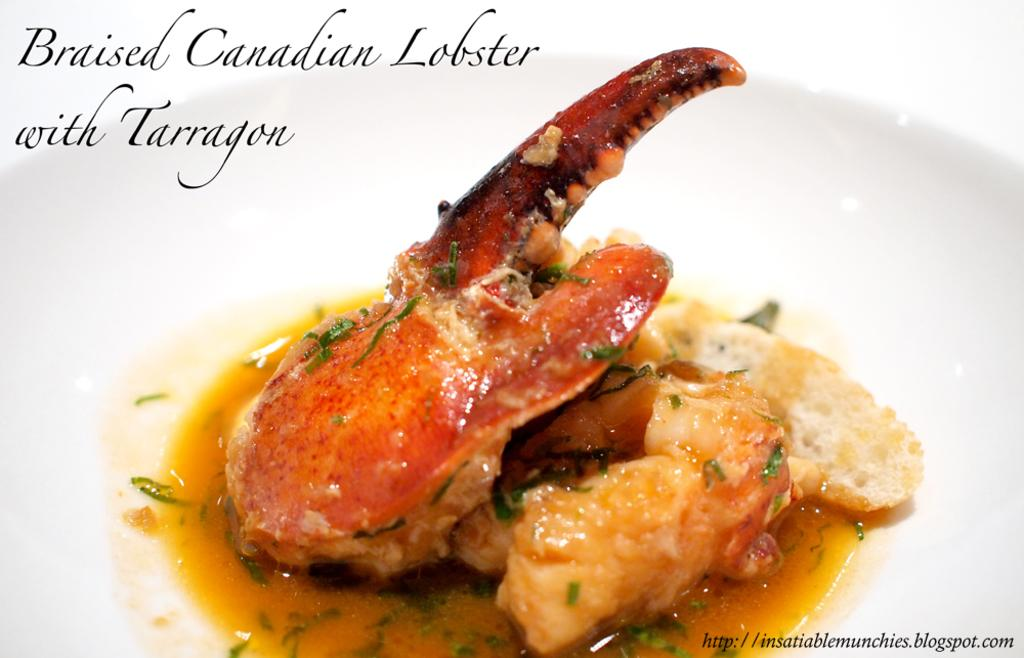What is on the white plate in the image? There are food items on a white plate in the image. Can you describe any other visual elements in the image? Yes, there are watermarks visible in the image. What type of eggs are being used to make the stew in the image? There is no stew or eggs present in the image; it only features food items on a white plate and watermarks. What role does the key play in the image? There is no key present in the image. 